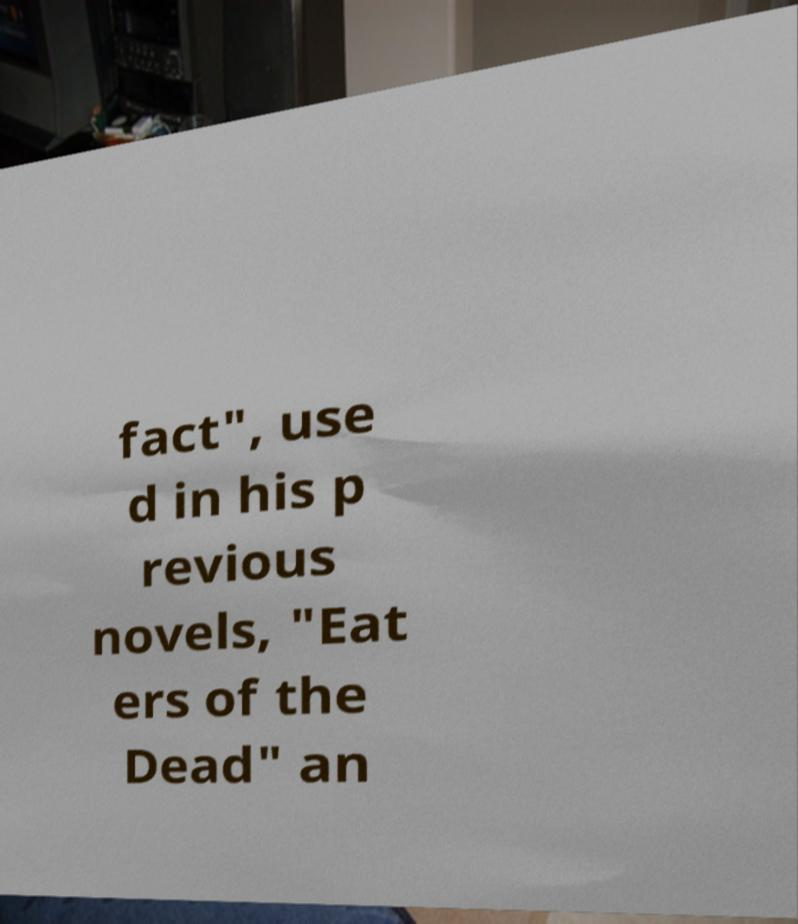Could you extract and type out the text from this image? fact", use d in his p revious novels, "Eat ers of the Dead" an 